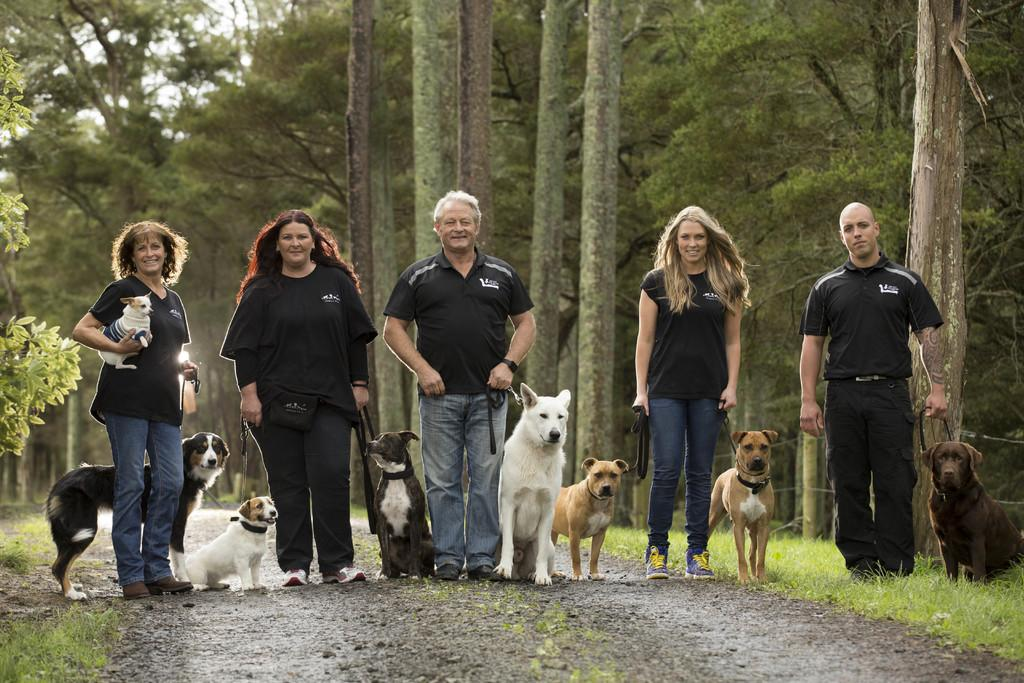What can be seen in the image? There are people standing in the image, and there are dogs in the image. Can you describe the interaction between the lady and the dog? A lady is holding a dog on the left side of the image. What is visible in the background of the image? There are trees in the background of the image. What type of ground is present at the bottom of the image? There is grass at the bottom of the image. What type of cabbage is being used to show respect to the trousers in the image? There is no cabbage or trousers present in the image, and no indication of respect being shown. 